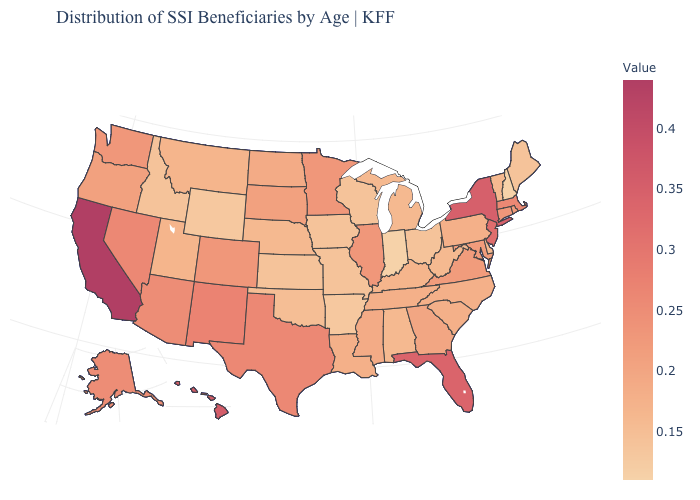Does Kentucky have the lowest value in the South?
Give a very brief answer. No. Which states hav the highest value in the Northeast?
Short answer required. New York. 